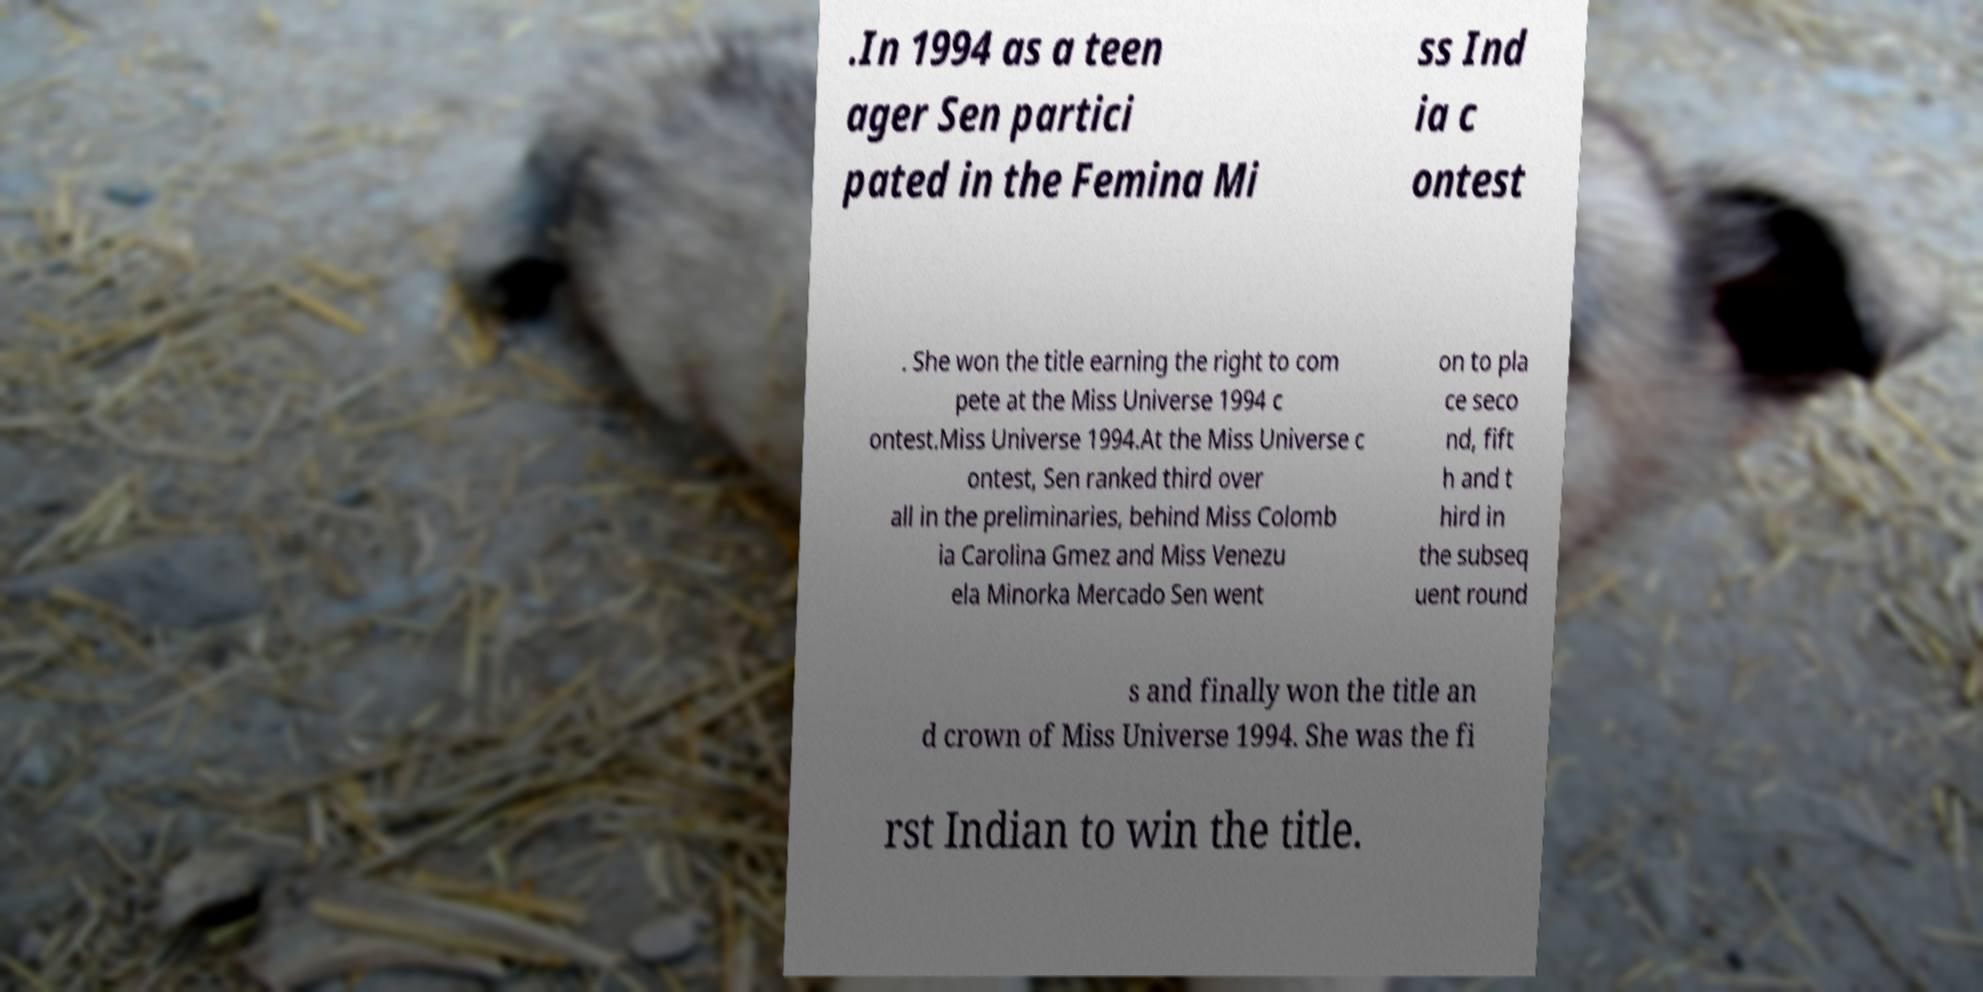What messages or text are displayed in this image? I need them in a readable, typed format. .In 1994 as a teen ager Sen partici pated in the Femina Mi ss Ind ia c ontest . She won the title earning the right to com pete at the Miss Universe 1994 c ontest.Miss Universe 1994.At the Miss Universe c ontest, Sen ranked third over all in the preliminaries, behind Miss Colomb ia Carolina Gmez and Miss Venezu ela Minorka Mercado Sen went on to pla ce seco nd, fift h and t hird in the subseq uent round s and finally won the title an d crown of Miss Universe 1994. She was the fi rst Indian to win the title. 